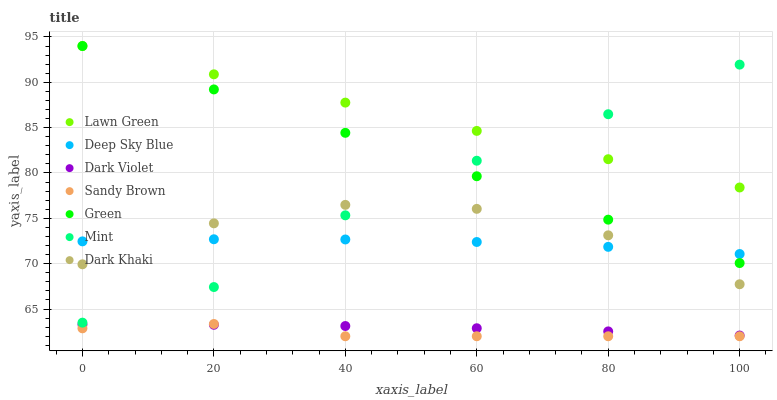Does Sandy Brown have the minimum area under the curve?
Answer yes or no. Yes. Does Lawn Green have the maximum area under the curve?
Answer yes or no. Yes. Does Mint have the minimum area under the curve?
Answer yes or no. No. Does Mint have the maximum area under the curve?
Answer yes or no. No. Is Green the smoothest?
Answer yes or no. Yes. Is Dark Khaki the roughest?
Answer yes or no. Yes. Is Mint the smoothest?
Answer yes or no. No. Is Mint the roughest?
Answer yes or no. No. Does Sandy Brown have the lowest value?
Answer yes or no. Yes. Does Mint have the lowest value?
Answer yes or no. No. Does Green have the highest value?
Answer yes or no. Yes. Does Mint have the highest value?
Answer yes or no. No. Is Dark Violet less than Mint?
Answer yes or no. Yes. Is Lawn Green greater than Deep Sky Blue?
Answer yes or no. Yes. Does Mint intersect Deep Sky Blue?
Answer yes or no. Yes. Is Mint less than Deep Sky Blue?
Answer yes or no. No. Is Mint greater than Deep Sky Blue?
Answer yes or no. No. Does Dark Violet intersect Mint?
Answer yes or no. No. 